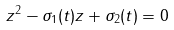<formula> <loc_0><loc_0><loc_500><loc_500>z ^ { 2 } - \sigma _ { 1 } ( t ) z + \sigma _ { 2 } ( t ) = 0</formula> 